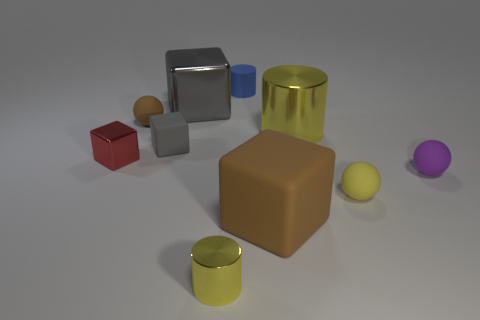Subtract all blue blocks. Subtract all yellow cylinders. How many blocks are left? 4 Subtract all spheres. How many objects are left? 7 Add 6 gray metal cubes. How many gray metal cubes are left? 7 Add 7 tiny red metallic cubes. How many tiny red metallic cubes exist? 8 Subtract 0 red cylinders. How many objects are left? 10 Subtract all yellow shiny cylinders. Subtract all tiny blue rubber cylinders. How many objects are left? 7 